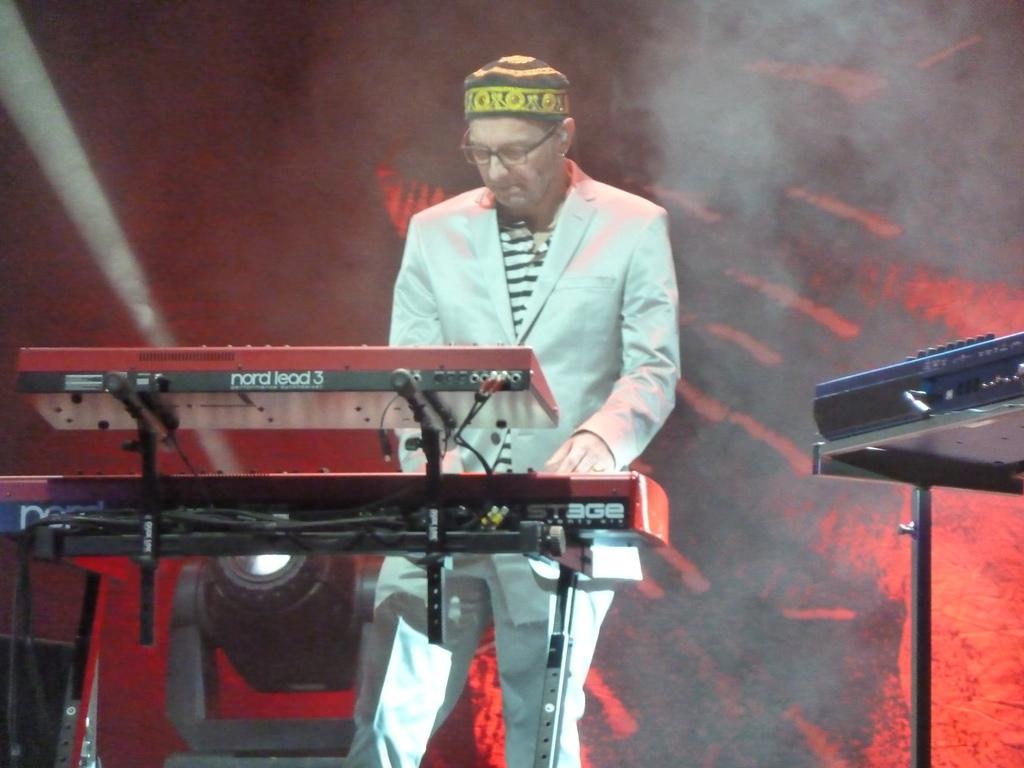Can you describe this image briefly? In the foreground of this picture, there is a man in cream suit standing and playing a piano. On the right side, there is another piano. In the background, there is a light and a wall. 